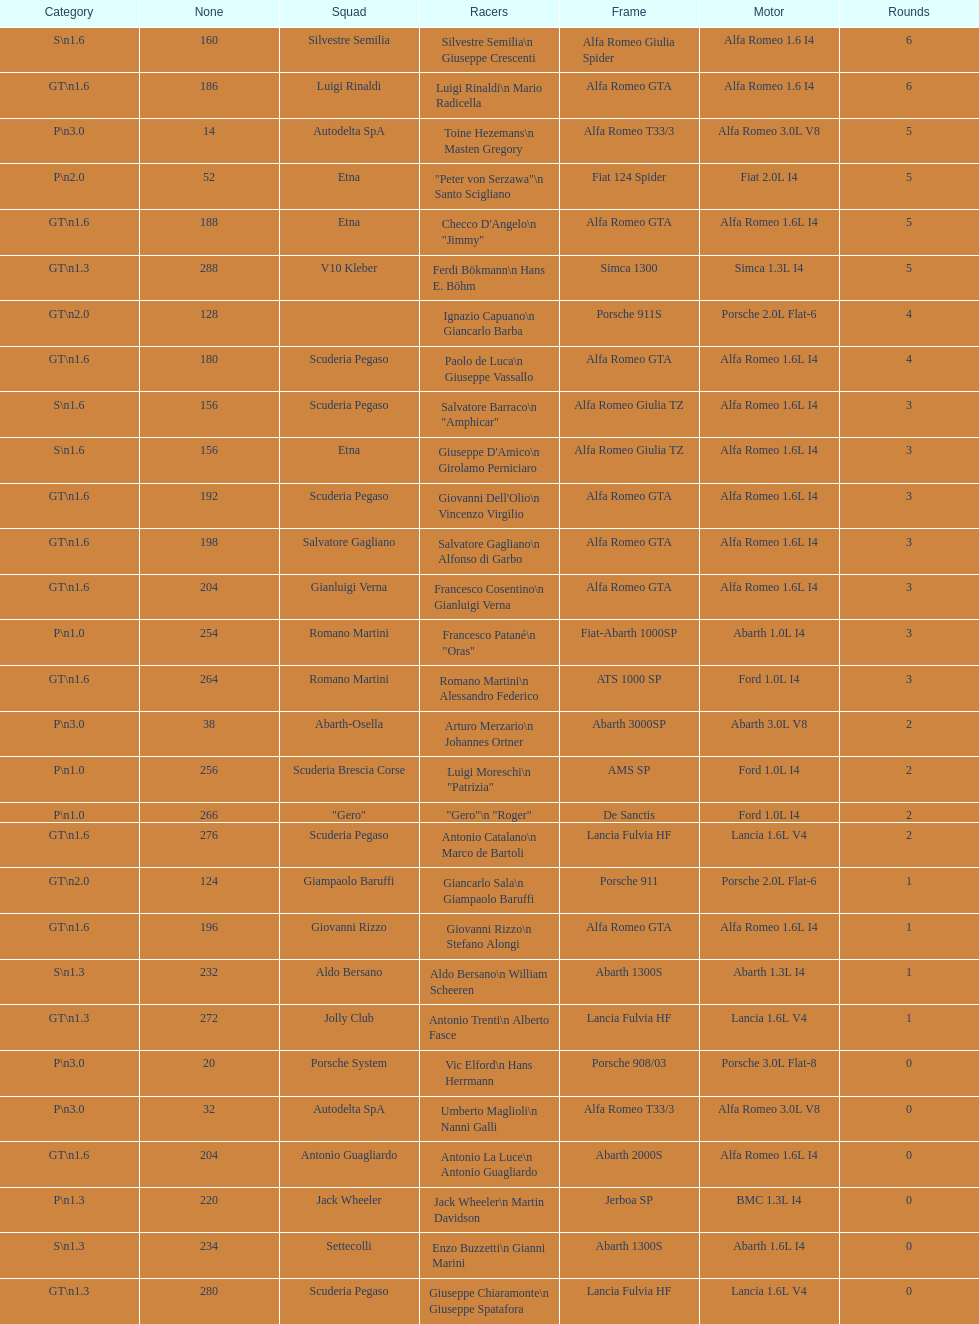What class is below s 1.6? GT 1.6. Would you mind parsing the complete table? {'header': ['Category', 'None', 'Squad', 'Racers', 'Frame', 'Motor', 'Rounds'], 'rows': [['S\\n1.6', '160', 'Silvestre Semilia', 'Silvestre Semilia\\n Giuseppe Crescenti', 'Alfa Romeo Giulia Spider', 'Alfa Romeo 1.6 I4', '6'], ['GT\\n1.6', '186', 'Luigi Rinaldi', 'Luigi Rinaldi\\n Mario Radicella', 'Alfa Romeo GTA', 'Alfa Romeo 1.6 I4', '6'], ['P\\n3.0', '14', 'Autodelta SpA', 'Toine Hezemans\\n Masten Gregory', 'Alfa Romeo T33/3', 'Alfa Romeo 3.0L V8', '5'], ['P\\n2.0', '52', 'Etna', '"Peter von Serzawa"\\n Santo Scigliano', 'Fiat 124 Spider', 'Fiat 2.0L I4', '5'], ['GT\\n1.6', '188', 'Etna', 'Checco D\'Angelo\\n "Jimmy"', 'Alfa Romeo GTA', 'Alfa Romeo 1.6L I4', '5'], ['GT\\n1.3', '288', 'V10 Kleber', 'Ferdi Bökmann\\n Hans E. Böhm', 'Simca 1300', 'Simca 1.3L I4', '5'], ['GT\\n2.0', '128', '', 'Ignazio Capuano\\n Giancarlo Barba', 'Porsche 911S', 'Porsche 2.0L Flat-6', '4'], ['GT\\n1.6', '180', 'Scuderia Pegaso', 'Paolo de Luca\\n Giuseppe Vassallo', 'Alfa Romeo GTA', 'Alfa Romeo 1.6L I4', '4'], ['S\\n1.6', '156', 'Scuderia Pegaso', 'Salvatore Barraco\\n "Amphicar"', 'Alfa Romeo Giulia TZ', 'Alfa Romeo 1.6L I4', '3'], ['S\\n1.6', '156', 'Etna', "Giuseppe D'Amico\\n Girolamo Perniciaro", 'Alfa Romeo Giulia TZ', 'Alfa Romeo 1.6L I4', '3'], ['GT\\n1.6', '192', 'Scuderia Pegaso', "Giovanni Dell'Olio\\n Vincenzo Virgilio", 'Alfa Romeo GTA', 'Alfa Romeo 1.6L I4', '3'], ['GT\\n1.6', '198', 'Salvatore Gagliano', 'Salvatore Gagliano\\n Alfonso di Garbo', 'Alfa Romeo GTA', 'Alfa Romeo 1.6L I4', '3'], ['GT\\n1.6', '204', 'Gianluigi Verna', 'Francesco Cosentino\\n Gianluigi Verna', 'Alfa Romeo GTA', 'Alfa Romeo 1.6L I4', '3'], ['P\\n1.0', '254', 'Romano Martini', 'Francesco Patané\\n "Oras"', 'Fiat-Abarth 1000SP', 'Abarth 1.0L I4', '3'], ['GT\\n1.6', '264', 'Romano Martini', 'Romano Martini\\n Alessandro Federico', 'ATS 1000 SP', 'Ford 1.0L I4', '3'], ['P\\n3.0', '38', 'Abarth-Osella', 'Arturo Merzario\\n Johannes Ortner', 'Abarth 3000SP', 'Abarth 3.0L V8', '2'], ['P\\n1.0', '256', 'Scuderia Brescia Corse', 'Luigi Moreschi\\n "Patrizia"', 'AMS SP', 'Ford 1.0L I4', '2'], ['P\\n1.0', '266', '"Gero"', '"Gero"\\n "Roger"', 'De Sanctis', 'Ford 1.0L I4', '2'], ['GT\\n1.6', '276', 'Scuderia Pegaso', 'Antonio Catalano\\n Marco de Bartoli', 'Lancia Fulvia HF', 'Lancia 1.6L V4', '2'], ['GT\\n2.0', '124', 'Giampaolo Baruffi', 'Giancarlo Sala\\n Giampaolo Baruffi', 'Porsche 911', 'Porsche 2.0L Flat-6', '1'], ['GT\\n1.6', '196', 'Giovanni Rizzo', 'Giovanni Rizzo\\n Stefano Alongi', 'Alfa Romeo GTA', 'Alfa Romeo 1.6L I4', '1'], ['S\\n1.3', '232', 'Aldo Bersano', 'Aldo Bersano\\n William Scheeren', 'Abarth 1300S', 'Abarth 1.3L I4', '1'], ['GT\\n1.3', '272', 'Jolly Club', 'Antonio Trenti\\n Alberto Fasce', 'Lancia Fulvia HF', 'Lancia 1.6L V4', '1'], ['P\\n3.0', '20', 'Porsche System', 'Vic Elford\\n Hans Herrmann', 'Porsche 908/03', 'Porsche 3.0L Flat-8', '0'], ['P\\n3.0', '32', 'Autodelta SpA', 'Umberto Maglioli\\n Nanni Galli', 'Alfa Romeo T33/3', 'Alfa Romeo 3.0L V8', '0'], ['GT\\n1.6', '204', 'Antonio Guagliardo', 'Antonio La Luce\\n Antonio Guagliardo', 'Abarth 2000S', 'Alfa Romeo 1.6L I4', '0'], ['P\\n1.3', '220', 'Jack Wheeler', 'Jack Wheeler\\n Martin Davidson', 'Jerboa SP', 'BMC 1.3L I4', '0'], ['S\\n1.3', '234', 'Settecolli', 'Enzo Buzzetti\\n Gianni Marini', 'Abarth 1300S', 'Abarth 1.6L I4', '0'], ['GT\\n1.3', '280', 'Scuderia Pegaso', 'Giuseppe Chiaramonte\\n Giuseppe Spatafora', 'Lancia Fulvia HF', 'Lancia 1.6L V4', '0']]} 